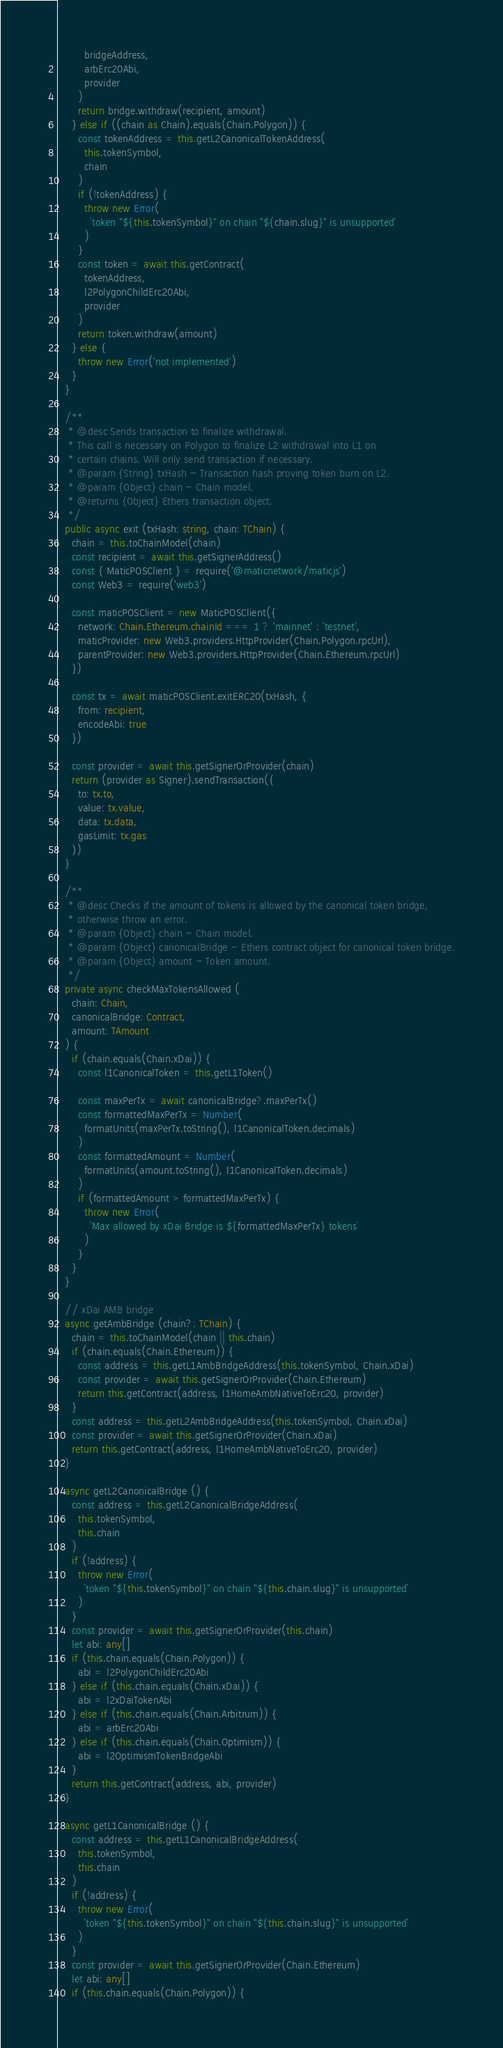Convert code to text. <code><loc_0><loc_0><loc_500><loc_500><_TypeScript_>        bridgeAddress,
        arbErc20Abi,
        provider
      )
      return bridge.withdraw(recipient, amount)
    } else if ((chain as Chain).equals(Chain.Polygon)) {
      const tokenAddress = this.getL2CanonicalTokenAddress(
        this.tokenSymbol,
        chain
      )
      if (!tokenAddress) {
        throw new Error(
          `token "${this.tokenSymbol}" on chain "${chain.slug}" is unsupported`
        )
      }
      const token = await this.getContract(
        tokenAddress,
        l2PolygonChildErc20Abi,
        provider
      )
      return token.withdraw(amount)
    } else {
      throw new Error('not implemented')
    }
  }

  /**
   * @desc Sends transaction to finalize withdrawal.
   * This call is necessary on Polygon to finalize L2 withdrawal into L1 on
   * certain chains. Will only send transaction if necessary.
   * @param {String} txHash - Transaction hash proving token burn on L2.
   * @param {Object} chain - Chain model.
   * @returns {Object} Ethers transaction object.
   */
  public async exit (txHash: string, chain: TChain) {
    chain = this.toChainModel(chain)
    const recipient = await this.getSignerAddress()
    const { MaticPOSClient } = require('@maticnetwork/maticjs')
    const Web3 = require('web3')

    const maticPOSClient = new MaticPOSClient({
      network: Chain.Ethereum.chainId === 1 ? 'mainnet' : 'testnet',
      maticProvider: new Web3.providers.HttpProvider(Chain.Polygon.rpcUrl),
      parentProvider: new Web3.providers.HttpProvider(Chain.Ethereum.rpcUrl)
    })

    const tx = await maticPOSClient.exitERC20(txHash, {
      from: recipient,
      encodeAbi: true
    })

    const provider = await this.getSignerOrProvider(chain)
    return (provider as Signer).sendTransaction({
      to: tx.to,
      value: tx.value,
      data: tx.data,
      gasLimit: tx.gas
    })
  }

  /**
   * @desc Checks if the amount of tokens is allowed by the canonical token bridge,
   * otherwise throw an error.
   * @param {Object} chain - Chain model.
   * @param {Object} canonicalBridge - Ethers contract object for canonical token bridge.
   * @param {Object} amount - Token amount.
   */
  private async checkMaxTokensAllowed (
    chain: Chain,
    canonicalBridge: Contract,
    amount: TAmount
  ) {
    if (chain.equals(Chain.xDai)) {
      const l1CanonicalToken = this.getL1Token()

      const maxPerTx = await canonicalBridge?.maxPerTx()
      const formattedMaxPerTx = Number(
        formatUnits(maxPerTx.toString(), l1CanonicalToken.decimals)
      )
      const formattedAmount = Number(
        formatUnits(amount.toString(), l1CanonicalToken.decimals)
      )
      if (formattedAmount > formattedMaxPerTx) {
        throw new Error(
          `Max allowed by xDai Bridge is ${formattedMaxPerTx} tokens`
        )
      }
    }
  }

  // xDai AMB bridge
  async getAmbBridge (chain?: TChain) {
    chain = this.toChainModel(chain || this.chain)
    if (chain.equals(Chain.Ethereum)) {
      const address = this.getL1AmbBridgeAddress(this.tokenSymbol, Chain.xDai)
      const provider = await this.getSignerOrProvider(Chain.Ethereum)
      return this.getContract(address, l1HomeAmbNativeToErc20, provider)
    }
    const address = this.getL2AmbBridgeAddress(this.tokenSymbol, Chain.xDai)
    const provider = await this.getSignerOrProvider(Chain.xDai)
    return this.getContract(address, l1HomeAmbNativeToErc20, provider)
  }

  async getL2CanonicalBridge () {
    const address = this.getL2CanonicalBridgeAddress(
      this.tokenSymbol,
      this.chain
    )
    if (!address) {
      throw new Error(
        `token "${this.tokenSymbol}" on chain "${this.chain.slug}" is unsupported`
      )
    }
    const provider = await this.getSignerOrProvider(this.chain)
    let abi: any[]
    if (this.chain.equals(Chain.Polygon)) {
      abi = l2PolygonChildErc20Abi
    } else if (this.chain.equals(Chain.xDai)) {
      abi = l2xDaiTokenAbi
    } else if (this.chain.equals(Chain.Arbitrum)) {
      abi = arbErc20Abi
    } else if (this.chain.equals(Chain.Optimism)) {
      abi = l2OptimismTokenBridgeAbi
    }
    return this.getContract(address, abi, provider)
  }

  async getL1CanonicalBridge () {
    const address = this.getL1CanonicalBridgeAddress(
      this.tokenSymbol,
      this.chain
    )
    if (!address) {
      throw new Error(
        `token "${this.tokenSymbol}" on chain "${this.chain.slug}" is unsupported`
      )
    }
    const provider = await this.getSignerOrProvider(Chain.Ethereum)
    let abi: any[]
    if (this.chain.equals(Chain.Polygon)) {</code> 